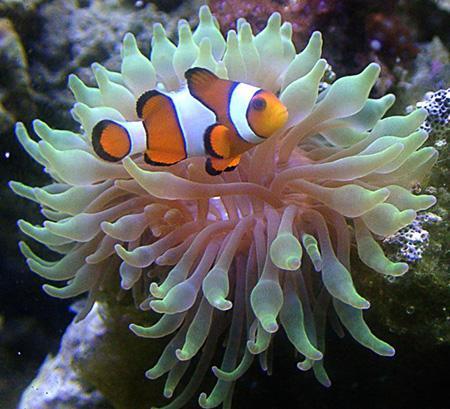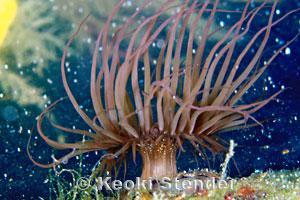The first image is the image on the left, the second image is the image on the right. Assess this claim about the two images: "The left and right image contains the same number of fish.". Correct or not? Answer yes or no. No. The first image is the image on the left, the second image is the image on the right. Examine the images to the left and right. Is the description "Several fish swim around the anemone in the image on the left, while a single fish swims in the image on the right." accurate? Answer yes or no. No. 